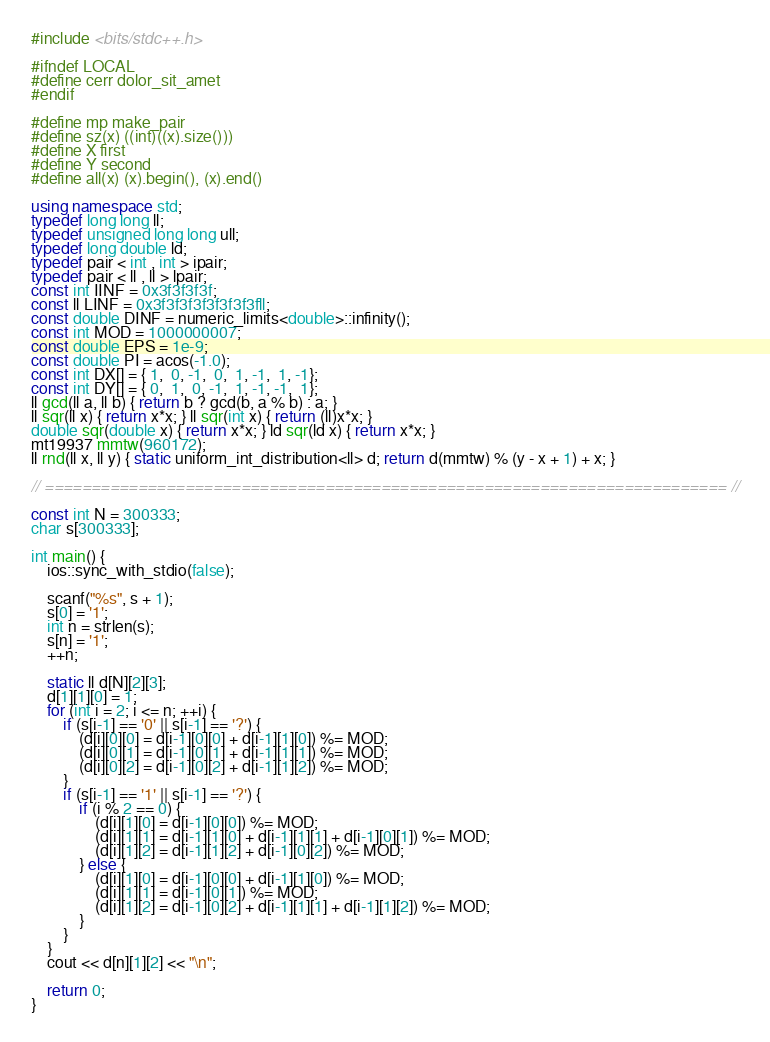<code> <loc_0><loc_0><loc_500><loc_500><_C++_>#include <bits/stdc++.h>

#ifndef LOCAL
#define cerr dolor_sit_amet
#endif

#define mp make_pair
#define sz(x) ((int)((x).size()))
#define X first
#define Y second
#define all(x) (x).begin(), (x).end()

using namespace std;
typedef long long ll;
typedef unsigned long long ull;
typedef long double ld;
typedef pair < int , int > ipair;
typedef pair < ll , ll > lpair;
const int IINF = 0x3f3f3f3f;
const ll LINF = 0x3f3f3f3f3f3f3f3fll;
const double DINF = numeric_limits<double>::infinity();
const int MOD = 1000000007;
const double EPS = 1e-9;
const double PI = acos(-1.0);
const int DX[] = { 1,  0, -1,  0,  1, -1,  1, -1};
const int DY[] = { 0,  1,  0, -1,  1, -1, -1,  1};
ll gcd(ll a, ll b) { return b ? gcd(b, a % b) : a; }
ll sqr(ll x) { return x*x; } ll sqr(int x) { return (ll)x*x; }
double sqr(double x) { return x*x; } ld sqr(ld x) { return x*x; }
mt19937 mmtw(960172);
ll rnd(ll x, ll y) { static uniform_int_distribution<ll> d; return d(mmtw) % (y - x + 1) + x; }

// ========================================================================= //

const int N = 300333;
char s[300333];

int main() {
    ios::sync_with_stdio(false);

    scanf("%s", s + 1);
    s[0] = '1';
    int n = strlen(s);
    s[n] = '1';
    ++n;

    static ll d[N][2][3];
    d[1][1][0] = 1;
    for (int i = 2; i <= n; ++i) {
        if (s[i-1] == '0' || s[i-1] == '?') {
            (d[i][0][0] = d[i-1][0][0] + d[i-1][1][0]) %= MOD;
            (d[i][0][1] = d[i-1][0][1] + d[i-1][1][1]) %= MOD;
            (d[i][0][2] = d[i-1][0][2] + d[i-1][1][2]) %= MOD;
        }
        if (s[i-1] == '1' || s[i-1] == '?') {
            if (i % 2 == 0) {
                (d[i][1][0] = d[i-1][0][0]) %= MOD;
                (d[i][1][1] = d[i-1][1][0] + d[i-1][1][1] + d[i-1][0][1]) %= MOD;
                (d[i][1][2] = d[i-1][1][2] + d[i-1][0][2]) %= MOD;
            } else {
                (d[i][1][0] = d[i-1][0][0] + d[i-1][1][0]) %= MOD;
                (d[i][1][1] = d[i-1][0][1]) %= MOD;
                (d[i][1][2] = d[i-1][0][2] + d[i-1][1][1] + d[i-1][1][2]) %= MOD;
            }
        }
    }
    cout << d[n][1][2] << "\n";

    return 0;
}
</code> 